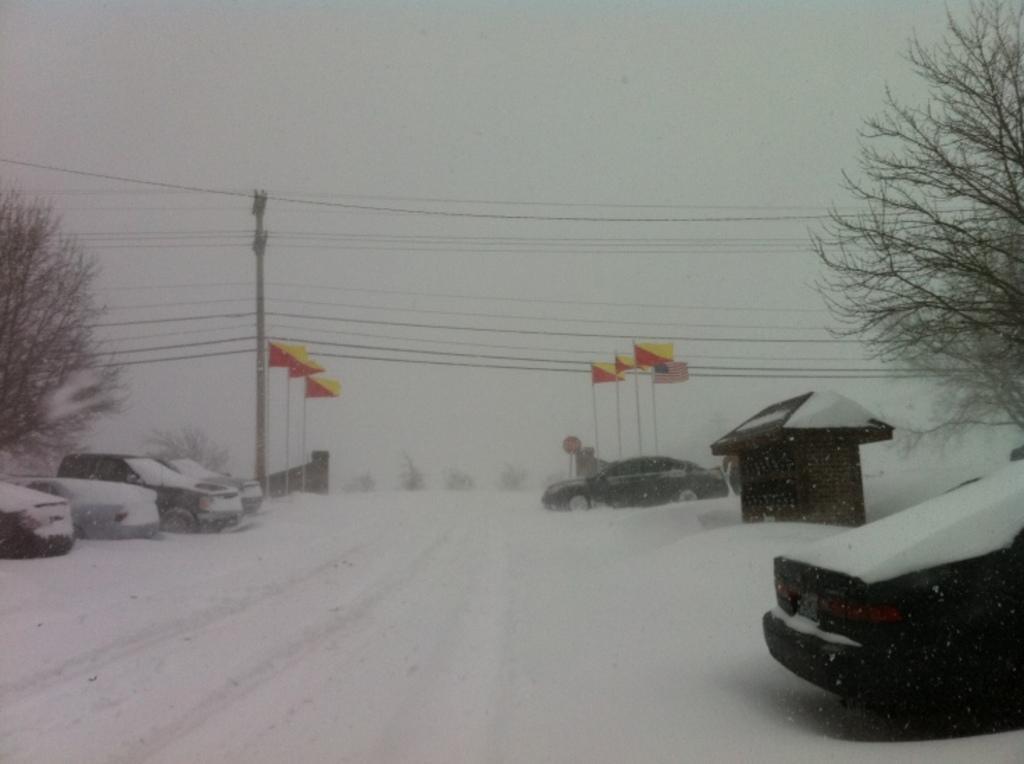Could you give a brief overview of what you see in this image? In this picture, we see many cars parked on the road. Beside that, we see an electric pole and wires. We see flags which are in red and yellow color. On either side of the picture, we see trees. On either side of the picture, we see the road covered with ice. At the top of the picture, we see the sky. 